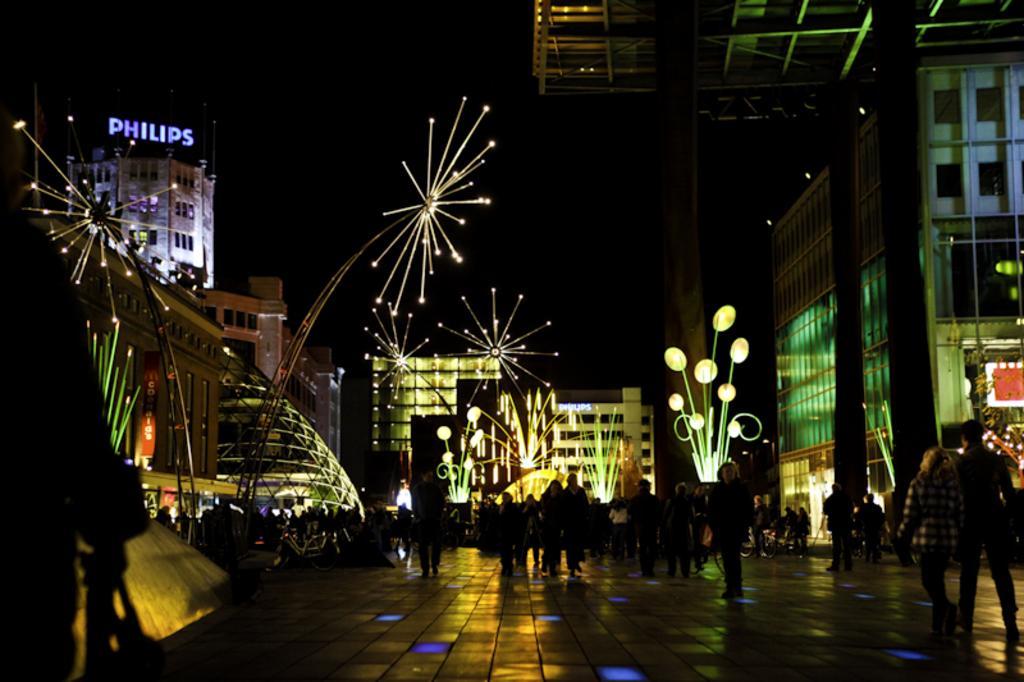Please provide a concise description of this image. In this picture we can see a group of people on the ground, here we can see buildings, lights, poles and some objects and in the background we can see it is dark. 